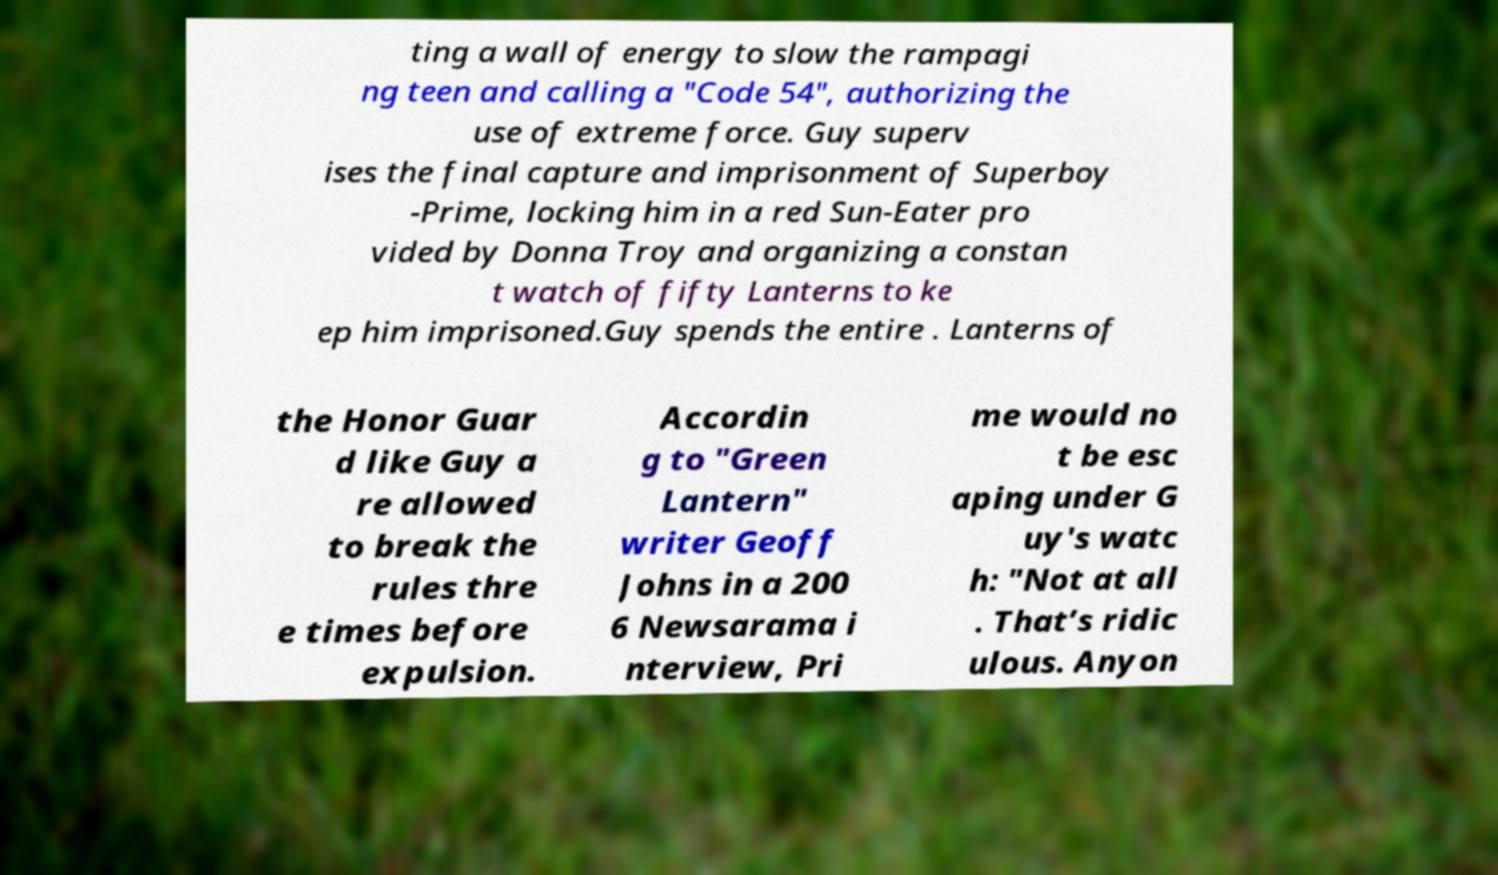Can you accurately transcribe the text from the provided image for me? ting a wall of energy to slow the rampagi ng teen and calling a "Code 54", authorizing the use of extreme force. Guy superv ises the final capture and imprisonment of Superboy -Prime, locking him in a red Sun-Eater pro vided by Donna Troy and organizing a constan t watch of fifty Lanterns to ke ep him imprisoned.Guy spends the entire . Lanterns of the Honor Guar d like Guy a re allowed to break the rules thre e times before expulsion. Accordin g to "Green Lantern" writer Geoff Johns in a 200 6 Newsarama i nterview, Pri me would no t be esc aping under G uy's watc h: "Not at all . That’s ridic ulous. Anyon 